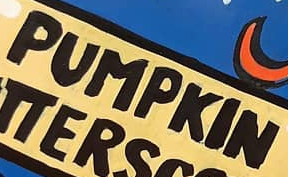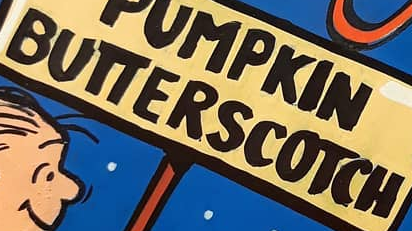Identify the words shown in these images in order, separated by a semicolon. PUMPKIN; BUTTERSCOTCH 